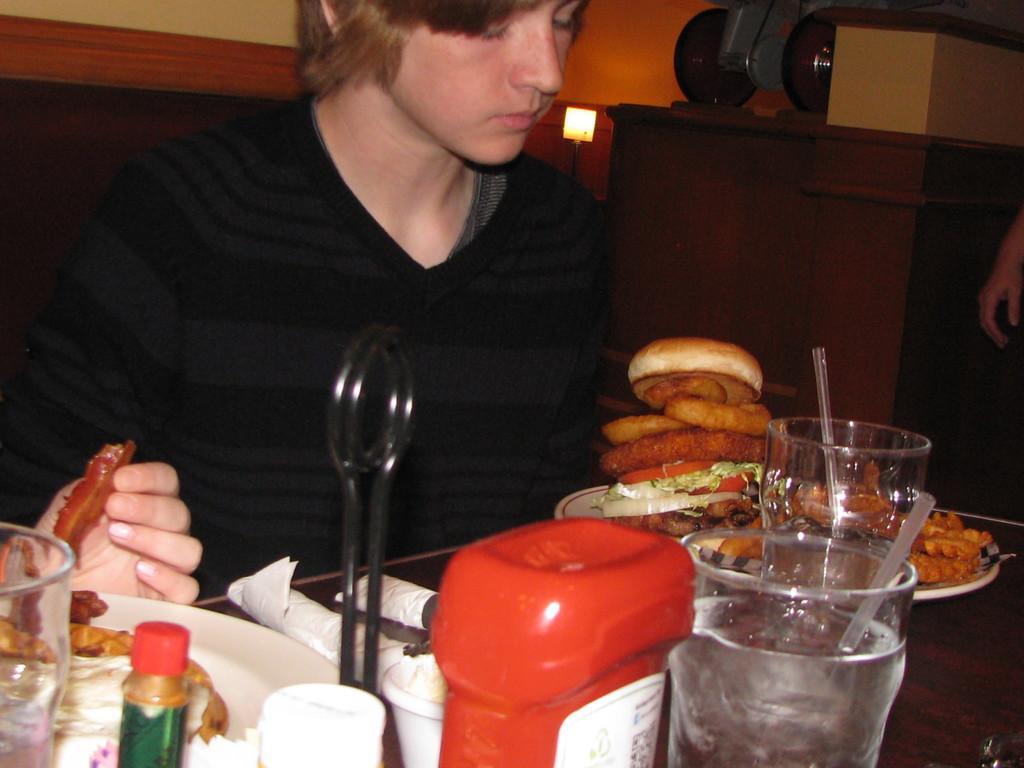Could you give a brief overview of what you see in this image? In the image we can see a man sitting and wearing clothes. Here we can see the table, on the table, we can see plate and food on a plate, glass, straw, tissue paper and other objects. Here we can see the lamp and the wall. We can see there are even other people. 